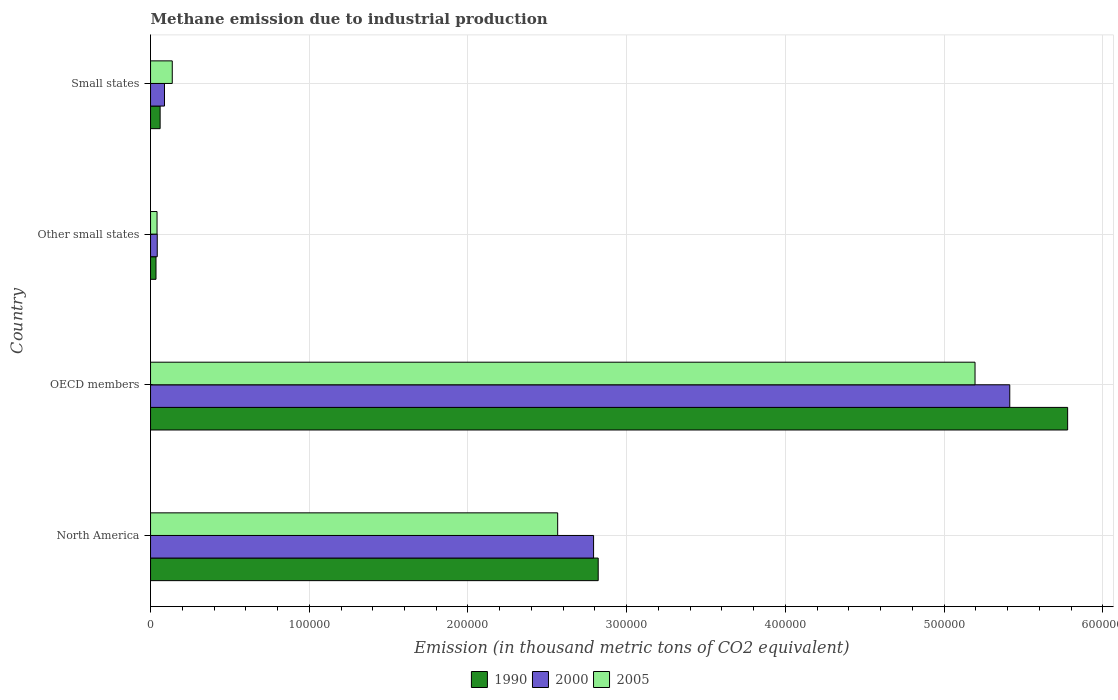How many different coloured bars are there?
Your answer should be very brief. 3. How many groups of bars are there?
Offer a very short reply. 4. Are the number of bars per tick equal to the number of legend labels?
Make the answer very short. Yes. How many bars are there on the 1st tick from the top?
Make the answer very short. 3. What is the label of the 1st group of bars from the top?
Make the answer very short. Small states. In how many cases, is the number of bars for a given country not equal to the number of legend labels?
Offer a very short reply. 0. What is the amount of methane emitted in 1990 in Other small states?
Your answer should be very brief. 3443.7. Across all countries, what is the maximum amount of methane emitted in 2005?
Provide a short and direct response. 5.19e+05. Across all countries, what is the minimum amount of methane emitted in 2000?
Provide a succinct answer. 4229.4. In which country was the amount of methane emitted in 1990 minimum?
Keep it short and to the point. Other small states. What is the total amount of methane emitted in 1990 in the graph?
Keep it short and to the point. 8.69e+05. What is the difference between the amount of methane emitted in 2000 in Other small states and that in Small states?
Offer a terse response. -4560.6. What is the difference between the amount of methane emitted in 2005 in Other small states and the amount of methane emitted in 1990 in Small states?
Your answer should be very brief. -1940.8. What is the average amount of methane emitted in 2005 per country?
Ensure brevity in your answer.  1.98e+05. What is the difference between the amount of methane emitted in 2005 and amount of methane emitted in 2000 in Other small states?
Give a very brief answer. -126.6. In how many countries, is the amount of methane emitted in 2005 greater than 580000 thousand metric tons?
Give a very brief answer. 0. What is the ratio of the amount of methane emitted in 2000 in OECD members to that in Other small states?
Keep it short and to the point. 128. Is the difference between the amount of methane emitted in 2005 in North America and Small states greater than the difference between the amount of methane emitted in 2000 in North America and Small states?
Your answer should be compact. No. What is the difference between the highest and the second highest amount of methane emitted in 1990?
Provide a succinct answer. 2.96e+05. What is the difference between the highest and the lowest amount of methane emitted in 2000?
Make the answer very short. 5.37e+05. In how many countries, is the amount of methane emitted in 2005 greater than the average amount of methane emitted in 2005 taken over all countries?
Your answer should be compact. 2. What does the 1st bar from the top in OECD members represents?
Ensure brevity in your answer.  2005. What does the 1st bar from the bottom in North America represents?
Provide a short and direct response. 1990. How many bars are there?
Provide a succinct answer. 12. Are all the bars in the graph horizontal?
Your answer should be very brief. Yes. How many countries are there in the graph?
Your response must be concise. 4. Does the graph contain grids?
Provide a short and direct response. Yes. Where does the legend appear in the graph?
Keep it short and to the point. Bottom center. How many legend labels are there?
Provide a short and direct response. 3. What is the title of the graph?
Ensure brevity in your answer.  Methane emission due to industrial production. Does "2003" appear as one of the legend labels in the graph?
Ensure brevity in your answer.  No. What is the label or title of the X-axis?
Ensure brevity in your answer.  Emission (in thousand metric tons of CO2 equivalent). What is the Emission (in thousand metric tons of CO2 equivalent) of 1990 in North America?
Keep it short and to the point. 2.82e+05. What is the Emission (in thousand metric tons of CO2 equivalent) of 2000 in North America?
Ensure brevity in your answer.  2.79e+05. What is the Emission (in thousand metric tons of CO2 equivalent) of 2005 in North America?
Ensure brevity in your answer.  2.57e+05. What is the Emission (in thousand metric tons of CO2 equivalent) of 1990 in OECD members?
Your response must be concise. 5.78e+05. What is the Emission (in thousand metric tons of CO2 equivalent) in 2000 in OECD members?
Keep it short and to the point. 5.41e+05. What is the Emission (in thousand metric tons of CO2 equivalent) of 2005 in OECD members?
Make the answer very short. 5.19e+05. What is the Emission (in thousand metric tons of CO2 equivalent) of 1990 in Other small states?
Your answer should be very brief. 3443.7. What is the Emission (in thousand metric tons of CO2 equivalent) of 2000 in Other small states?
Provide a short and direct response. 4229.4. What is the Emission (in thousand metric tons of CO2 equivalent) of 2005 in Other small states?
Give a very brief answer. 4102.8. What is the Emission (in thousand metric tons of CO2 equivalent) in 1990 in Small states?
Provide a succinct answer. 6043.6. What is the Emission (in thousand metric tons of CO2 equivalent) in 2000 in Small states?
Give a very brief answer. 8790. What is the Emission (in thousand metric tons of CO2 equivalent) of 2005 in Small states?
Your answer should be very brief. 1.37e+04. Across all countries, what is the maximum Emission (in thousand metric tons of CO2 equivalent) of 1990?
Your response must be concise. 5.78e+05. Across all countries, what is the maximum Emission (in thousand metric tons of CO2 equivalent) of 2000?
Ensure brevity in your answer.  5.41e+05. Across all countries, what is the maximum Emission (in thousand metric tons of CO2 equivalent) of 2005?
Make the answer very short. 5.19e+05. Across all countries, what is the minimum Emission (in thousand metric tons of CO2 equivalent) in 1990?
Offer a terse response. 3443.7. Across all countries, what is the minimum Emission (in thousand metric tons of CO2 equivalent) of 2000?
Offer a very short reply. 4229.4. Across all countries, what is the minimum Emission (in thousand metric tons of CO2 equivalent) of 2005?
Offer a terse response. 4102.8. What is the total Emission (in thousand metric tons of CO2 equivalent) in 1990 in the graph?
Ensure brevity in your answer.  8.69e+05. What is the total Emission (in thousand metric tons of CO2 equivalent) in 2000 in the graph?
Provide a short and direct response. 8.33e+05. What is the total Emission (in thousand metric tons of CO2 equivalent) of 2005 in the graph?
Your response must be concise. 7.94e+05. What is the difference between the Emission (in thousand metric tons of CO2 equivalent) in 1990 in North America and that in OECD members?
Offer a very short reply. -2.96e+05. What is the difference between the Emission (in thousand metric tons of CO2 equivalent) of 2000 in North America and that in OECD members?
Ensure brevity in your answer.  -2.62e+05. What is the difference between the Emission (in thousand metric tons of CO2 equivalent) of 2005 in North America and that in OECD members?
Ensure brevity in your answer.  -2.63e+05. What is the difference between the Emission (in thousand metric tons of CO2 equivalent) in 1990 in North America and that in Other small states?
Make the answer very short. 2.79e+05. What is the difference between the Emission (in thousand metric tons of CO2 equivalent) of 2000 in North America and that in Other small states?
Offer a terse response. 2.75e+05. What is the difference between the Emission (in thousand metric tons of CO2 equivalent) in 2005 in North America and that in Other small states?
Your response must be concise. 2.52e+05. What is the difference between the Emission (in thousand metric tons of CO2 equivalent) of 1990 in North America and that in Small states?
Make the answer very short. 2.76e+05. What is the difference between the Emission (in thousand metric tons of CO2 equivalent) of 2000 in North America and that in Small states?
Offer a terse response. 2.70e+05. What is the difference between the Emission (in thousand metric tons of CO2 equivalent) in 2005 in North America and that in Small states?
Provide a succinct answer. 2.43e+05. What is the difference between the Emission (in thousand metric tons of CO2 equivalent) of 1990 in OECD members and that in Other small states?
Provide a short and direct response. 5.74e+05. What is the difference between the Emission (in thousand metric tons of CO2 equivalent) in 2000 in OECD members and that in Other small states?
Your response must be concise. 5.37e+05. What is the difference between the Emission (in thousand metric tons of CO2 equivalent) in 2005 in OECD members and that in Other small states?
Your answer should be compact. 5.15e+05. What is the difference between the Emission (in thousand metric tons of CO2 equivalent) of 1990 in OECD members and that in Small states?
Your answer should be compact. 5.72e+05. What is the difference between the Emission (in thousand metric tons of CO2 equivalent) in 2000 in OECD members and that in Small states?
Provide a succinct answer. 5.33e+05. What is the difference between the Emission (in thousand metric tons of CO2 equivalent) of 2005 in OECD members and that in Small states?
Keep it short and to the point. 5.06e+05. What is the difference between the Emission (in thousand metric tons of CO2 equivalent) of 1990 in Other small states and that in Small states?
Your answer should be very brief. -2599.9. What is the difference between the Emission (in thousand metric tons of CO2 equivalent) of 2000 in Other small states and that in Small states?
Offer a terse response. -4560.6. What is the difference between the Emission (in thousand metric tons of CO2 equivalent) in 2005 in Other small states and that in Small states?
Keep it short and to the point. -9586.6. What is the difference between the Emission (in thousand metric tons of CO2 equivalent) in 1990 in North America and the Emission (in thousand metric tons of CO2 equivalent) in 2000 in OECD members?
Make the answer very short. -2.59e+05. What is the difference between the Emission (in thousand metric tons of CO2 equivalent) in 1990 in North America and the Emission (in thousand metric tons of CO2 equivalent) in 2005 in OECD members?
Your answer should be compact. -2.37e+05. What is the difference between the Emission (in thousand metric tons of CO2 equivalent) of 2000 in North America and the Emission (in thousand metric tons of CO2 equivalent) of 2005 in OECD members?
Offer a terse response. -2.40e+05. What is the difference between the Emission (in thousand metric tons of CO2 equivalent) of 1990 in North America and the Emission (in thousand metric tons of CO2 equivalent) of 2000 in Other small states?
Your answer should be very brief. 2.78e+05. What is the difference between the Emission (in thousand metric tons of CO2 equivalent) in 1990 in North America and the Emission (in thousand metric tons of CO2 equivalent) in 2005 in Other small states?
Offer a terse response. 2.78e+05. What is the difference between the Emission (in thousand metric tons of CO2 equivalent) of 2000 in North America and the Emission (in thousand metric tons of CO2 equivalent) of 2005 in Other small states?
Your answer should be very brief. 2.75e+05. What is the difference between the Emission (in thousand metric tons of CO2 equivalent) in 1990 in North America and the Emission (in thousand metric tons of CO2 equivalent) in 2000 in Small states?
Offer a very short reply. 2.73e+05. What is the difference between the Emission (in thousand metric tons of CO2 equivalent) in 1990 in North America and the Emission (in thousand metric tons of CO2 equivalent) in 2005 in Small states?
Offer a terse response. 2.68e+05. What is the difference between the Emission (in thousand metric tons of CO2 equivalent) of 2000 in North America and the Emission (in thousand metric tons of CO2 equivalent) of 2005 in Small states?
Provide a succinct answer. 2.65e+05. What is the difference between the Emission (in thousand metric tons of CO2 equivalent) of 1990 in OECD members and the Emission (in thousand metric tons of CO2 equivalent) of 2000 in Other small states?
Offer a very short reply. 5.74e+05. What is the difference between the Emission (in thousand metric tons of CO2 equivalent) of 1990 in OECD members and the Emission (in thousand metric tons of CO2 equivalent) of 2005 in Other small states?
Give a very brief answer. 5.74e+05. What is the difference between the Emission (in thousand metric tons of CO2 equivalent) of 2000 in OECD members and the Emission (in thousand metric tons of CO2 equivalent) of 2005 in Other small states?
Give a very brief answer. 5.37e+05. What is the difference between the Emission (in thousand metric tons of CO2 equivalent) of 1990 in OECD members and the Emission (in thousand metric tons of CO2 equivalent) of 2000 in Small states?
Your answer should be compact. 5.69e+05. What is the difference between the Emission (in thousand metric tons of CO2 equivalent) in 1990 in OECD members and the Emission (in thousand metric tons of CO2 equivalent) in 2005 in Small states?
Provide a short and direct response. 5.64e+05. What is the difference between the Emission (in thousand metric tons of CO2 equivalent) in 2000 in OECD members and the Emission (in thousand metric tons of CO2 equivalent) in 2005 in Small states?
Make the answer very short. 5.28e+05. What is the difference between the Emission (in thousand metric tons of CO2 equivalent) in 1990 in Other small states and the Emission (in thousand metric tons of CO2 equivalent) in 2000 in Small states?
Your answer should be very brief. -5346.3. What is the difference between the Emission (in thousand metric tons of CO2 equivalent) of 1990 in Other small states and the Emission (in thousand metric tons of CO2 equivalent) of 2005 in Small states?
Ensure brevity in your answer.  -1.02e+04. What is the difference between the Emission (in thousand metric tons of CO2 equivalent) in 2000 in Other small states and the Emission (in thousand metric tons of CO2 equivalent) in 2005 in Small states?
Offer a terse response. -9460. What is the average Emission (in thousand metric tons of CO2 equivalent) of 1990 per country?
Ensure brevity in your answer.  2.17e+05. What is the average Emission (in thousand metric tons of CO2 equivalent) of 2000 per country?
Offer a terse response. 2.08e+05. What is the average Emission (in thousand metric tons of CO2 equivalent) in 2005 per country?
Offer a terse response. 1.98e+05. What is the difference between the Emission (in thousand metric tons of CO2 equivalent) in 1990 and Emission (in thousand metric tons of CO2 equivalent) in 2000 in North America?
Make the answer very short. 2915.4. What is the difference between the Emission (in thousand metric tons of CO2 equivalent) of 1990 and Emission (in thousand metric tons of CO2 equivalent) of 2005 in North America?
Ensure brevity in your answer.  2.55e+04. What is the difference between the Emission (in thousand metric tons of CO2 equivalent) of 2000 and Emission (in thousand metric tons of CO2 equivalent) of 2005 in North America?
Offer a terse response. 2.26e+04. What is the difference between the Emission (in thousand metric tons of CO2 equivalent) in 1990 and Emission (in thousand metric tons of CO2 equivalent) in 2000 in OECD members?
Ensure brevity in your answer.  3.65e+04. What is the difference between the Emission (in thousand metric tons of CO2 equivalent) of 1990 and Emission (in thousand metric tons of CO2 equivalent) of 2005 in OECD members?
Give a very brief answer. 5.83e+04. What is the difference between the Emission (in thousand metric tons of CO2 equivalent) of 2000 and Emission (in thousand metric tons of CO2 equivalent) of 2005 in OECD members?
Offer a terse response. 2.19e+04. What is the difference between the Emission (in thousand metric tons of CO2 equivalent) in 1990 and Emission (in thousand metric tons of CO2 equivalent) in 2000 in Other small states?
Give a very brief answer. -785.7. What is the difference between the Emission (in thousand metric tons of CO2 equivalent) in 1990 and Emission (in thousand metric tons of CO2 equivalent) in 2005 in Other small states?
Offer a terse response. -659.1. What is the difference between the Emission (in thousand metric tons of CO2 equivalent) in 2000 and Emission (in thousand metric tons of CO2 equivalent) in 2005 in Other small states?
Your answer should be very brief. 126.6. What is the difference between the Emission (in thousand metric tons of CO2 equivalent) of 1990 and Emission (in thousand metric tons of CO2 equivalent) of 2000 in Small states?
Your answer should be compact. -2746.4. What is the difference between the Emission (in thousand metric tons of CO2 equivalent) in 1990 and Emission (in thousand metric tons of CO2 equivalent) in 2005 in Small states?
Offer a very short reply. -7645.8. What is the difference between the Emission (in thousand metric tons of CO2 equivalent) of 2000 and Emission (in thousand metric tons of CO2 equivalent) of 2005 in Small states?
Offer a very short reply. -4899.4. What is the ratio of the Emission (in thousand metric tons of CO2 equivalent) in 1990 in North America to that in OECD members?
Keep it short and to the point. 0.49. What is the ratio of the Emission (in thousand metric tons of CO2 equivalent) of 2000 in North America to that in OECD members?
Give a very brief answer. 0.52. What is the ratio of the Emission (in thousand metric tons of CO2 equivalent) of 2005 in North America to that in OECD members?
Offer a terse response. 0.49. What is the ratio of the Emission (in thousand metric tons of CO2 equivalent) in 1990 in North America to that in Other small states?
Your answer should be very brief. 81.9. What is the ratio of the Emission (in thousand metric tons of CO2 equivalent) in 2000 in North America to that in Other small states?
Ensure brevity in your answer.  66. What is the ratio of the Emission (in thousand metric tons of CO2 equivalent) in 2005 in North America to that in Other small states?
Provide a short and direct response. 62.52. What is the ratio of the Emission (in thousand metric tons of CO2 equivalent) of 1990 in North America to that in Small states?
Ensure brevity in your answer.  46.67. What is the ratio of the Emission (in thousand metric tons of CO2 equivalent) of 2000 in North America to that in Small states?
Give a very brief answer. 31.76. What is the ratio of the Emission (in thousand metric tons of CO2 equivalent) of 2005 in North America to that in Small states?
Your answer should be compact. 18.74. What is the ratio of the Emission (in thousand metric tons of CO2 equivalent) in 1990 in OECD members to that in Other small states?
Provide a short and direct response. 167.79. What is the ratio of the Emission (in thousand metric tons of CO2 equivalent) of 2000 in OECD members to that in Other small states?
Ensure brevity in your answer.  128. What is the ratio of the Emission (in thousand metric tons of CO2 equivalent) of 2005 in OECD members to that in Other small states?
Make the answer very short. 126.61. What is the ratio of the Emission (in thousand metric tons of CO2 equivalent) of 1990 in OECD members to that in Small states?
Make the answer very short. 95.61. What is the ratio of the Emission (in thousand metric tons of CO2 equivalent) of 2000 in OECD members to that in Small states?
Your answer should be very brief. 61.59. What is the ratio of the Emission (in thousand metric tons of CO2 equivalent) in 2005 in OECD members to that in Small states?
Offer a very short reply. 37.95. What is the ratio of the Emission (in thousand metric tons of CO2 equivalent) of 1990 in Other small states to that in Small states?
Make the answer very short. 0.57. What is the ratio of the Emission (in thousand metric tons of CO2 equivalent) of 2000 in Other small states to that in Small states?
Keep it short and to the point. 0.48. What is the ratio of the Emission (in thousand metric tons of CO2 equivalent) in 2005 in Other small states to that in Small states?
Give a very brief answer. 0.3. What is the difference between the highest and the second highest Emission (in thousand metric tons of CO2 equivalent) of 1990?
Keep it short and to the point. 2.96e+05. What is the difference between the highest and the second highest Emission (in thousand metric tons of CO2 equivalent) of 2000?
Provide a short and direct response. 2.62e+05. What is the difference between the highest and the second highest Emission (in thousand metric tons of CO2 equivalent) of 2005?
Keep it short and to the point. 2.63e+05. What is the difference between the highest and the lowest Emission (in thousand metric tons of CO2 equivalent) in 1990?
Your answer should be compact. 5.74e+05. What is the difference between the highest and the lowest Emission (in thousand metric tons of CO2 equivalent) of 2000?
Provide a succinct answer. 5.37e+05. What is the difference between the highest and the lowest Emission (in thousand metric tons of CO2 equivalent) of 2005?
Keep it short and to the point. 5.15e+05. 